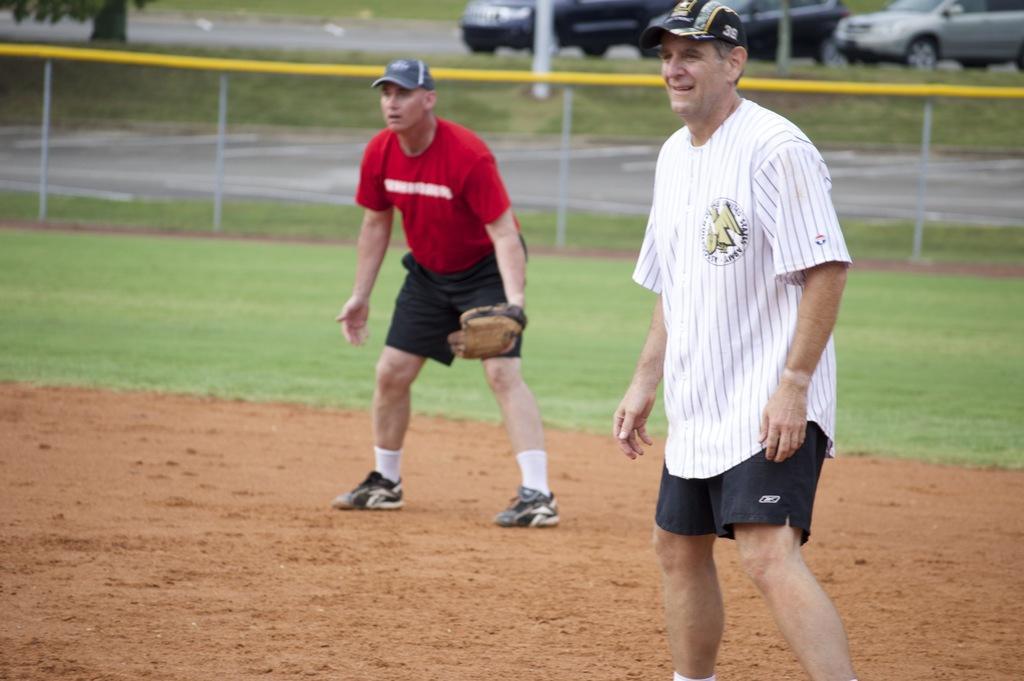In one or two sentences, can you explain what this image depicts? In this picture there are two persons standing. At the back there is a fence and there are vehicles and there is a tree. At the bottom there is ground and there is grass and there is a road. 